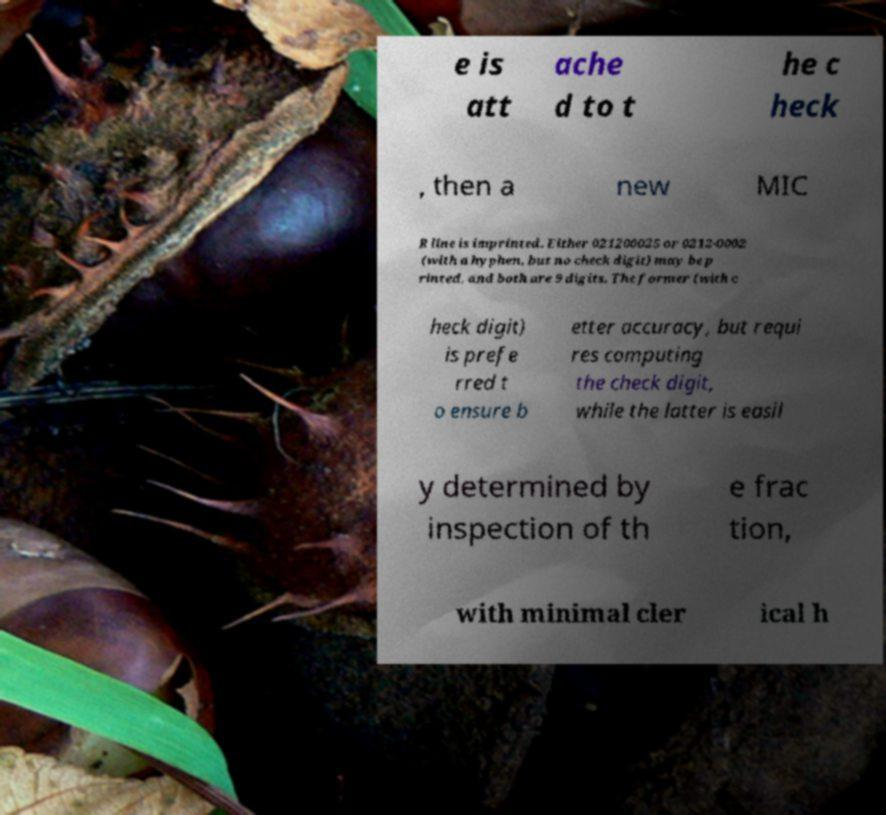For documentation purposes, I need the text within this image transcribed. Could you provide that? e is att ache d to t he c heck , then a new MIC R line is imprinted. Either 021200025 or 0212-0002 (with a hyphen, but no check digit) may be p rinted, and both are 9 digits. The former (with c heck digit) is prefe rred t o ensure b etter accuracy, but requi res computing the check digit, while the latter is easil y determined by inspection of th e frac tion, with minimal cler ical h 